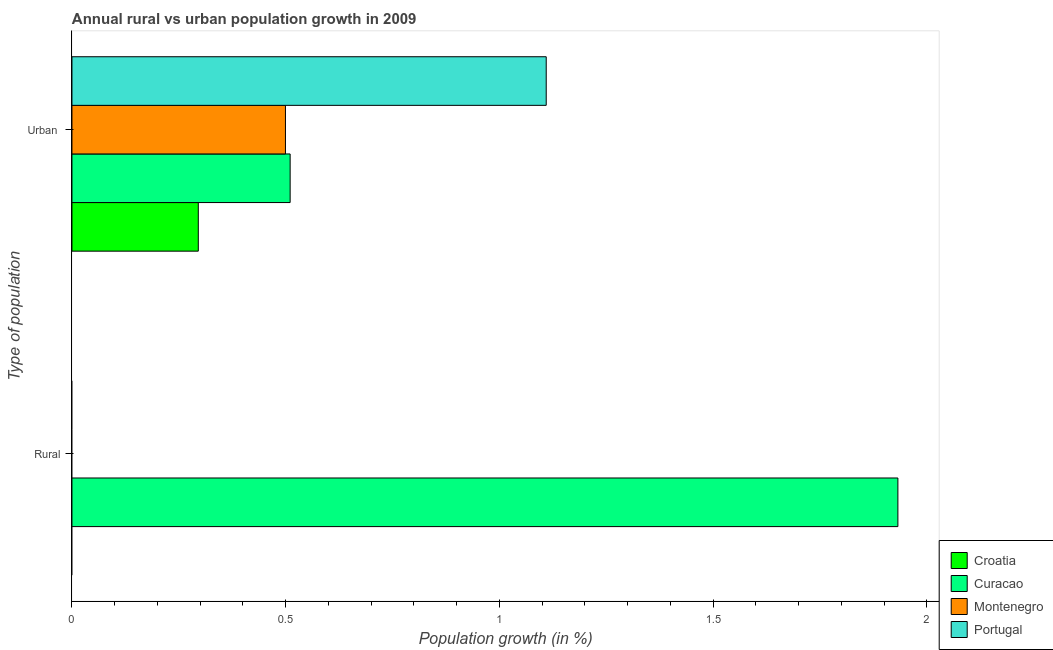What is the label of the 1st group of bars from the top?
Your answer should be very brief. Urban . What is the rural population growth in Portugal?
Your answer should be very brief. 0. Across all countries, what is the maximum urban population growth?
Offer a terse response. 1.11. In which country was the rural population growth maximum?
Keep it short and to the point. Curacao. What is the total urban population growth in the graph?
Offer a terse response. 2.41. What is the difference between the urban population growth in Croatia and that in Curacao?
Offer a terse response. -0.21. What is the difference between the urban population growth in Montenegro and the rural population growth in Curacao?
Keep it short and to the point. -1.43. What is the average rural population growth per country?
Offer a very short reply. 0.48. What is the difference between the urban population growth and rural population growth in Curacao?
Keep it short and to the point. -1.42. In how many countries, is the urban population growth greater than 0.4 %?
Make the answer very short. 3. What is the ratio of the urban population growth in Montenegro to that in Portugal?
Give a very brief answer. 0.45. Is the urban population growth in Curacao less than that in Portugal?
Keep it short and to the point. Yes. How many bars are there?
Offer a very short reply. 5. Are all the bars in the graph horizontal?
Offer a very short reply. Yes. Are the values on the major ticks of X-axis written in scientific E-notation?
Your response must be concise. No. Does the graph contain any zero values?
Give a very brief answer. Yes. How many legend labels are there?
Your response must be concise. 4. How are the legend labels stacked?
Keep it short and to the point. Vertical. What is the title of the graph?
Provide a succinct answer. Annual rural vs urban population growth in 2009. What is the label or title of the X-axis?
Make the answer very short. Population growth (in %). What is the label or title of the Y-axis?
Offer a very short reply. Type of population. What is the Population growth (in %) in Curacao in Rural?
Make the answer very short. 1.93. What is the Population growth (in %) in Portugal in Rural?
Keep it short and to the point. 0. What is the Population growth (in %) in Croatia in Urban ?
Your answer should be compact. 0.3. What is the Population growth (in %) of Curacao in Urban ?
Offer a very short reply. 0.51. What is the Population growth (in %) in Montenegro in Urban ?
Provide a short and direct response. 0.5. What is the Population growth (in %) of Portugal in Urban ?
Your answer should be compact. 1.11. Across all Type of population, what is the maximum Population growth (in %) of Croatia?
Provide a short and direct response. 0.3. Across all Type of population, what is the maximum Population growth (in %) of Curacao?
Offer a terse response. 1.93. Across all Type of population, what is the maximum Population growth (in %) of Montenegro?
Provide a short and direct response. 0.5. Across all Type of population, what is the maximum Population growth (in %) of Portugal?
Give a very brief answer. 1.11. Across all Type of population, what is the minimum Population growth (in %) of Croatia?
Your answer should be very brief. 0. Across all Type of population, what is the minimum Population growth (in %) of Curacao?
Your answer should be compact. 0.51. Across all Type of population, what is the minimum Population growth (in %) in Montenegro?
Keep it short and to the point. 0. What is the total Population growth (in %) in Croatia in the graph?
Your answer should be compact. 0.3. What is the total Population growth (in %) in Curacao in the graph?
Offer a very short reply. 2.44. What is the total Population growth (in %) of Montenegro in the graph?
Your response must be concise. 0.5. What is the total Population growth (in %) of Portugal in the graph?
Offer a terse response. 1.11. What is the difference between the Population growth (in %) of Curacao in Rural and that in Urban ?
Offer a very short reply. 1.42. What is the difference between the Population growth (in %) in Curacao in Rural and the Population growth (in %) in Montenegro in Urban ?
Offer a very short reply. 1.43. What is the difference between the Population growth (in %) of Curacao in Rural and the Population growth (in %) of Portugal in Urban ?
Provide a short and direct response. 0.82. What is the average Population growth (in %) of Croatia per Type of population?
Provide a short and direct response. 0.15. What is the average Population growth (in %) of Curacao per Type of population?
Ensure brevity in your answer.  1.22. What is the average Population growth (in %) of Montenegro per Type of population?
Offer a very short reply. 0.25. What is the average Population growth (in %) of Portugal per Type of population?
Keep it short and to the point. 0.55. What is the difference between the Population growth (in %) in Croatia and Population growth (in %) in Curacao in Urban ?
Offer a very short reply. -0.21. What is the difference between the Population growth (in %) in Croatia and Population growth (in %) in Montenegro in Urban ?
Provide a succinct answer. -0.2. What is the difference between the Population growth (in %) of Croatia and Population growth (in %) of Portugal in Urban ?
Make the answer very short. -0.81. What is the difference between the Population growth (in %) of Curacao and Population growth (in %) of Montenegro in Urban ?
Your answer should be very brief. 0.01. What is the difference between the Population growth (in %) in Curacao and Population growth (in %) in Portugal in Urban ?
Ensure brevity in your answer.  -0.6. What is the difference between the Population growth (in %) in Montenegro and Population growth (in %) in Portugal in Urban ?
Offer a very short reply. -0.61. What is the ratio of the Population growth (in %) of Curacao in Rural to that in Urban ?
Your answer should be very brief. 3.79. What is the difference between the highest and the second highest Population growth (in %) in Curacao?
Your answer should be very brief. 1.42. What is the difference between the highest and the lowest Population growth (in %) of Croatia?
Give a very brief answer. 0.3. What is the difference between the highest and the lowest Population growth (in %) of Curacao?
Provide a short and direct response. 1.42. What is the difference between the highest and the lowest Population growth (in %) in Montenegro?
Make the answer very short. 0.5. What is the difference between the highest and the lowest Population growth (in %) in Portugal?
Make the answer very short. 1.11. 